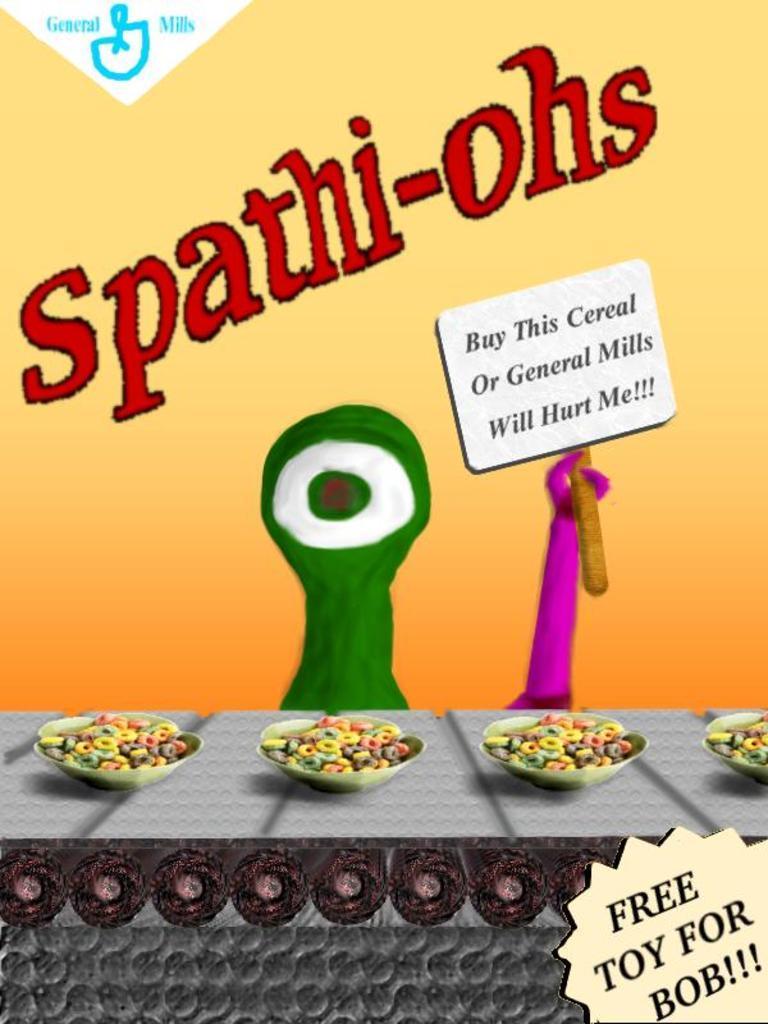In one or two sentences, can you explain what this image depicts? In the picture we can see a cereal advertisement with some bowls of cereals on it and a name on it as Spat hi-ohs. 